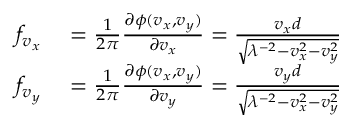Convert formula to latex. <formula><loc_0><loc_0><loc_500><loc_500>\begin{array} { r l } { f _ { v _ { x } } } & = \frac { 1 } { 2 \pi } \frac { \partial \phi ( v _ { x } , v _ { y } ) } { \partial v _ { x } } = \frac { v _ { x } d } { \sqrt { \lambda ^ { - 2 } - v _ { x } ^ { 2 } - v _ { y } ^ { 2 } } } } \\ { f _ { v _ { y } } } & = \frac { 1 } { 2 \pi } \frac { \partial \phi ( v _ { x } , v _ { y } ) } { \partial v _ { y } } = \frac { v _ { y } d } { \sqrt { \lambda ^ { - 2 } - v _ { x } ^ { 2 } - v _ { y } ^ { 2 } } } } \end{array}</formula> 